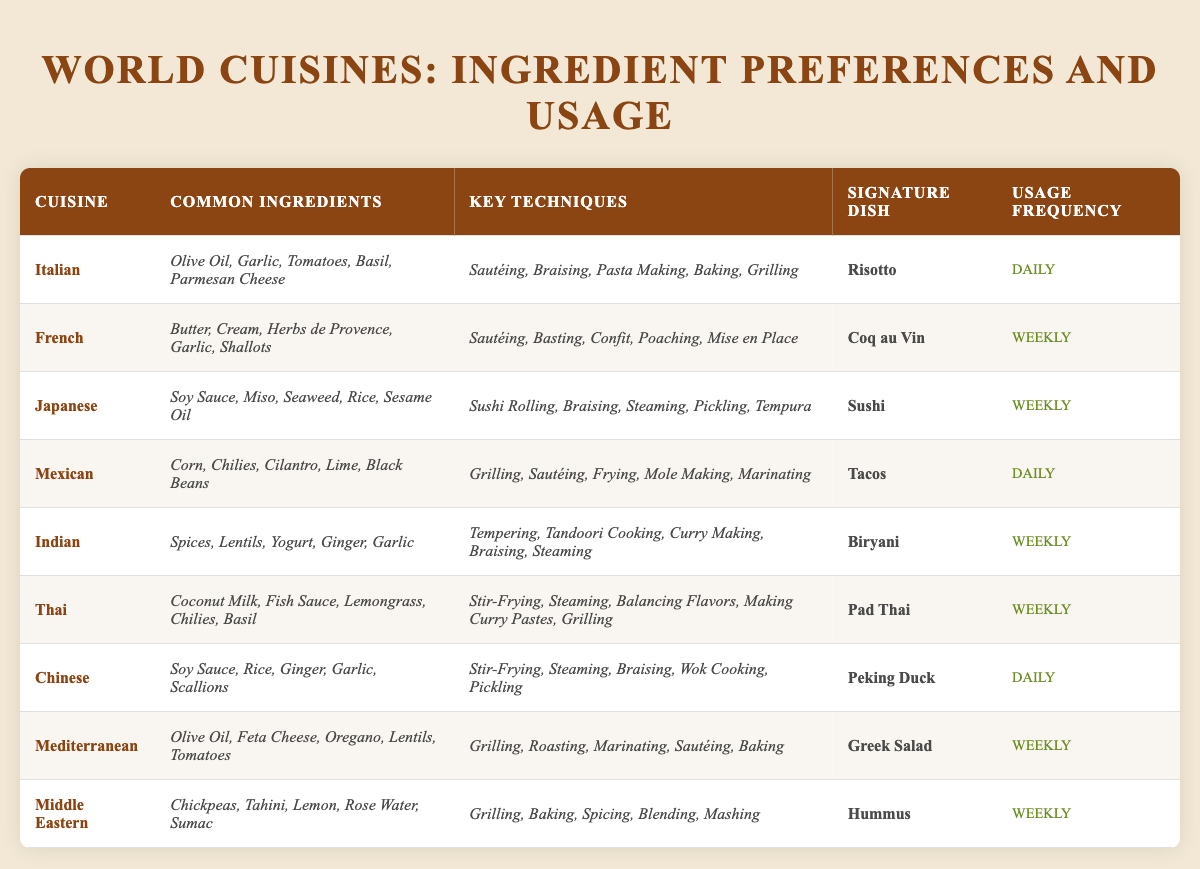What are the common ingredients in Italian cuisine? The table lists the common ingredients for each cuisine. For Italian cuisine, they are Olive Oil, Garlic, Tomatoes, Basil, and Parmesan Cheese.
Answer: Olive Oil, Garlic, Tomatoes, Basil, Parmesan Cheese Which cuisine has a signature dish of Sushi? By looking at the signature dishes for each cuisine, I can identify that the cuisine with Sushi as its signature dish is Japanese.
Answer: Japanese What is the usage frequency of Mediterranean cuisine? The table denotes the usage frequency next to each cuisine. For Mediterranean cuisine, it states Weekly.
Answer: Weekly How many cuisines use Garlic as a common ingredient? Looking at the common ingredients for each cuisine, I find Garlic appears in Italian, French, Japanese, Chinese, and Indian cuisines, totaling 5 cuisines.
Answer: 5 Is Tacos more commonly used than Coq au Vin? The usage frequency for Tacos is Daily and for Coq au Vin is Weekly. Since Daily is more frequent than Weekly, Tacos are used more commonly.
Answer: Yes List the key techniques used in Thai cuisine. The table specifies the key techniques for each cuisine. For Thai cuisine, they are Stir-Frying, Steaming, Balancing Flavors, Making Curry Pastes, and Grilling.
Answer: Stir-Frying, Steaming, Balancing Flavors, Making Curry Pastes, Grilling Which cuisine employs the technique of Tandoori Cooking? The table attributes the technique of Tandoori Cooking to Indian cuisine.
Answer: Indian How many cuisines have Daily as their usage frequency? By scanning the table, I find that Italian, Mexican, and Chinese cuisines have a usage frequency of Daily, which sums up to 3 cuisines.
Answer: 3 What signature dish corresponds with the Middle Eastern cuisine? From the table, the signature dish for Middle Eastern cuisine is identified as Hummus.
Answer: Hummus Which cuisine uses Fish Sauce among its common ingredients? The table indicates that Thai cuisine includes Fish Sauce as one of its common ingredients.
Answer: Thai 